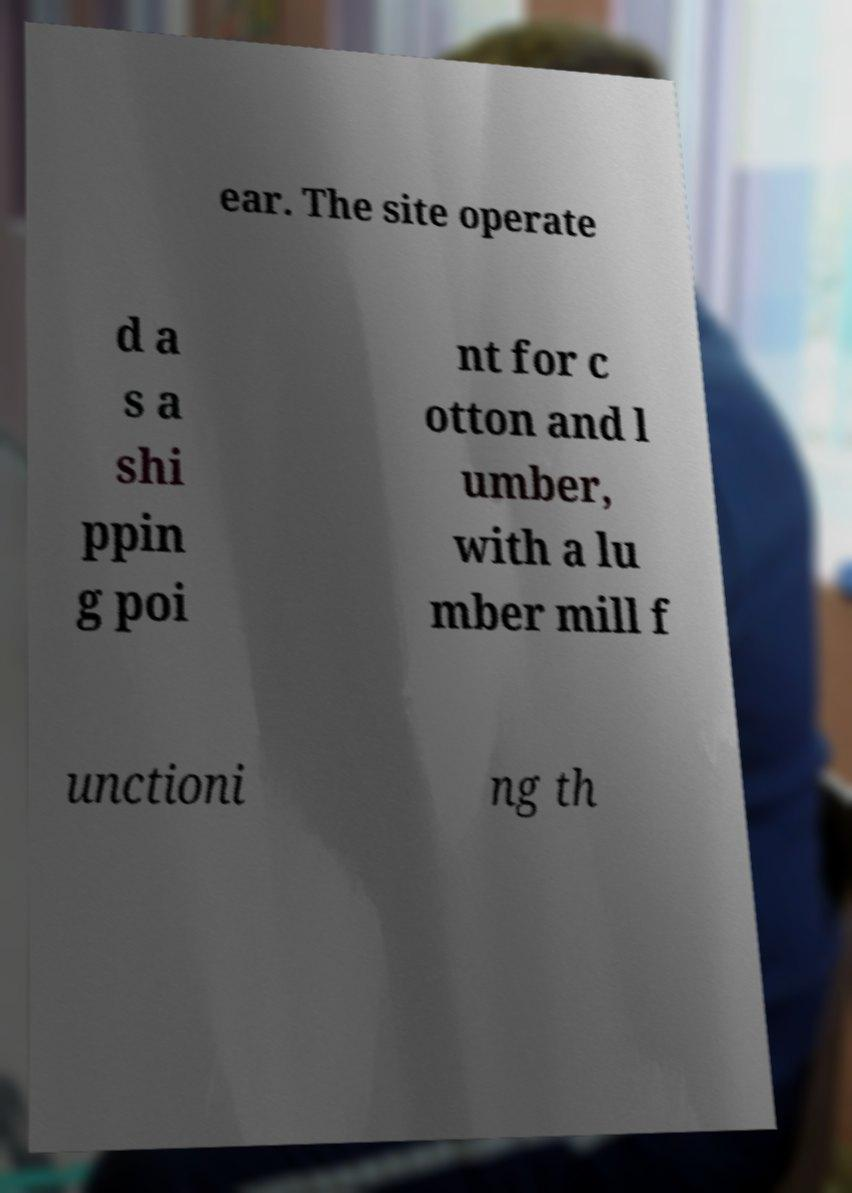What messages or text are displayed in this image? I need them in a readable, typed format. ear. The site operate d a s a shi ppin g poi nt for c otton and l umber, with a lu mber mill f unctioni ng th 